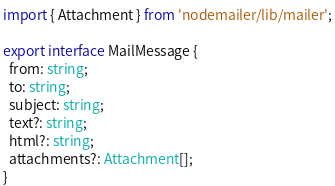Convert code to text. <code><loc_0><loc_0><loc_500><loc_500><_TypeScript_>import { Attachment } from 'nodemailer/lib/mailer';

export interface MailMessage {
  from: string;
  to: string;
  subject: string;
  text?: string;
  html?: string;
  attachments?: Attachment[];
}

</code> 